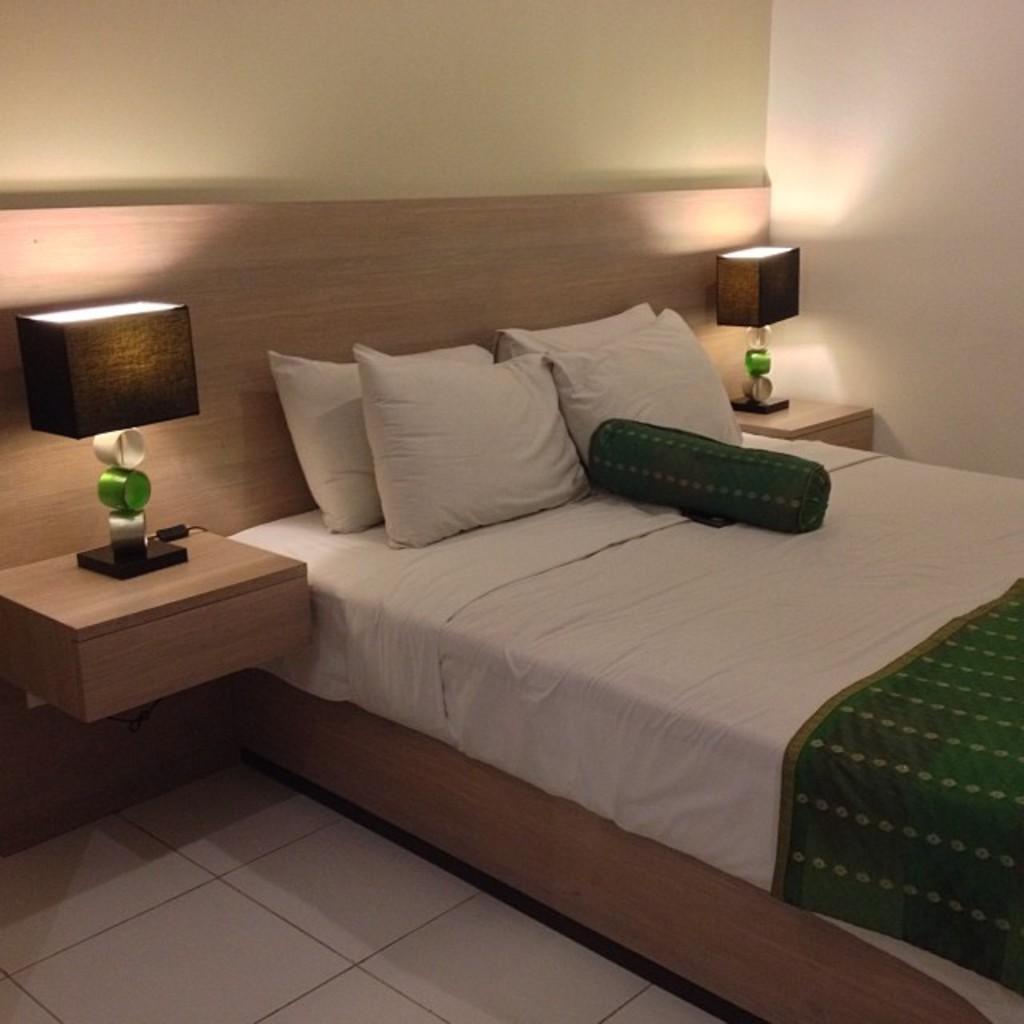Please provide a concise description of this image. In this image I see a bed, few pillows on it and lamps on the either side. In the background I see the wall. 